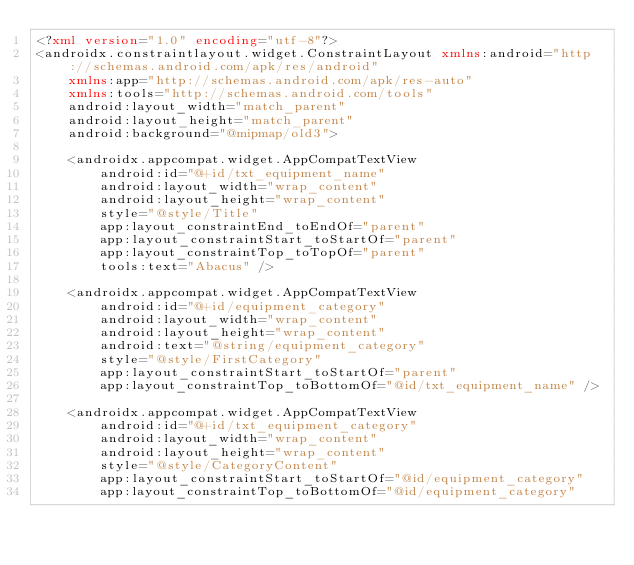Convert code to text. <code><loc_0><loc_0><loc_500><loc_500><_XML_><?xml version="1.0" encoding="utf-8"?>
<androidx.constraintlayout.widget.ConstraintLayout xmlns:android="http://schemas.android.com/apk/res/android"
    xmlns:app="http://schemas.android.com/apk/res-auto"
    xmlns:tools="http://schemas.android.com/tools"
    android:layout_width="match_parent"
    android:layout_height="match_parent"
    android:background="@mipmap/old3">

    <androidx.appcompat.widget.AppCompatTextView
        android:id="@+id/txt_equipment_name"
        android:layout_width="wrap_content"
        android:layout_height="wrap_content"
        style="@style/Title"
        app:layout_constraintEnd_toEndOf="parent"
        app:layout_constraintStart_toStartOf="parent"
        app:layout_constraintTop_toTopOf="parent"
        tools:text="Abacus" />

    <androidx.appcompat.widget.AppCompatTextView
        android:id="@+id/equipment_category"
        android:layout_width="wrap_content"
        android:layout_height="wrap_content"
        android:text="@string/equipment_category"
        style="@style/FirstCategory"
        app:layout_constraintStart_toStartOf="parent"
        app:layout_constraintTop_toBottomOf="@id/txt_equipment_name" />

    <androidx.appcompat.widget.AppCompatTextView
        android:id="@+id/txt_equipment_category"
        android:layout_width="wrap_content"
        android:layout_height="wrap_content"
        style="@style/CategoryContent"
        app:layout_constraintStart_toStartOf="@id/equipment_category"
        app:layout_constraintTop_toBottomOf="@id/equipment_category"</code> 